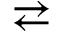<formula> <loc_0><loc_0><loc_500><loc_500>\right l e f t a r r o w s</formula> 